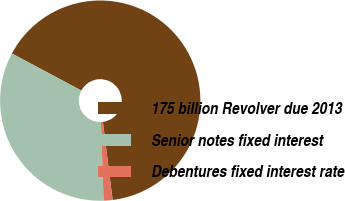Convert chart. <chart><loc_0><loc_0><loc_500><loc_500><pie_chart><fcel>175 billion Revolver due 2013<fcel>Senior notes fixed interest<fcel>Debentures fixed interest rate<nl><fcel>65.23%<fcel>33.33%<fcel>1.44%<nl></chart> 